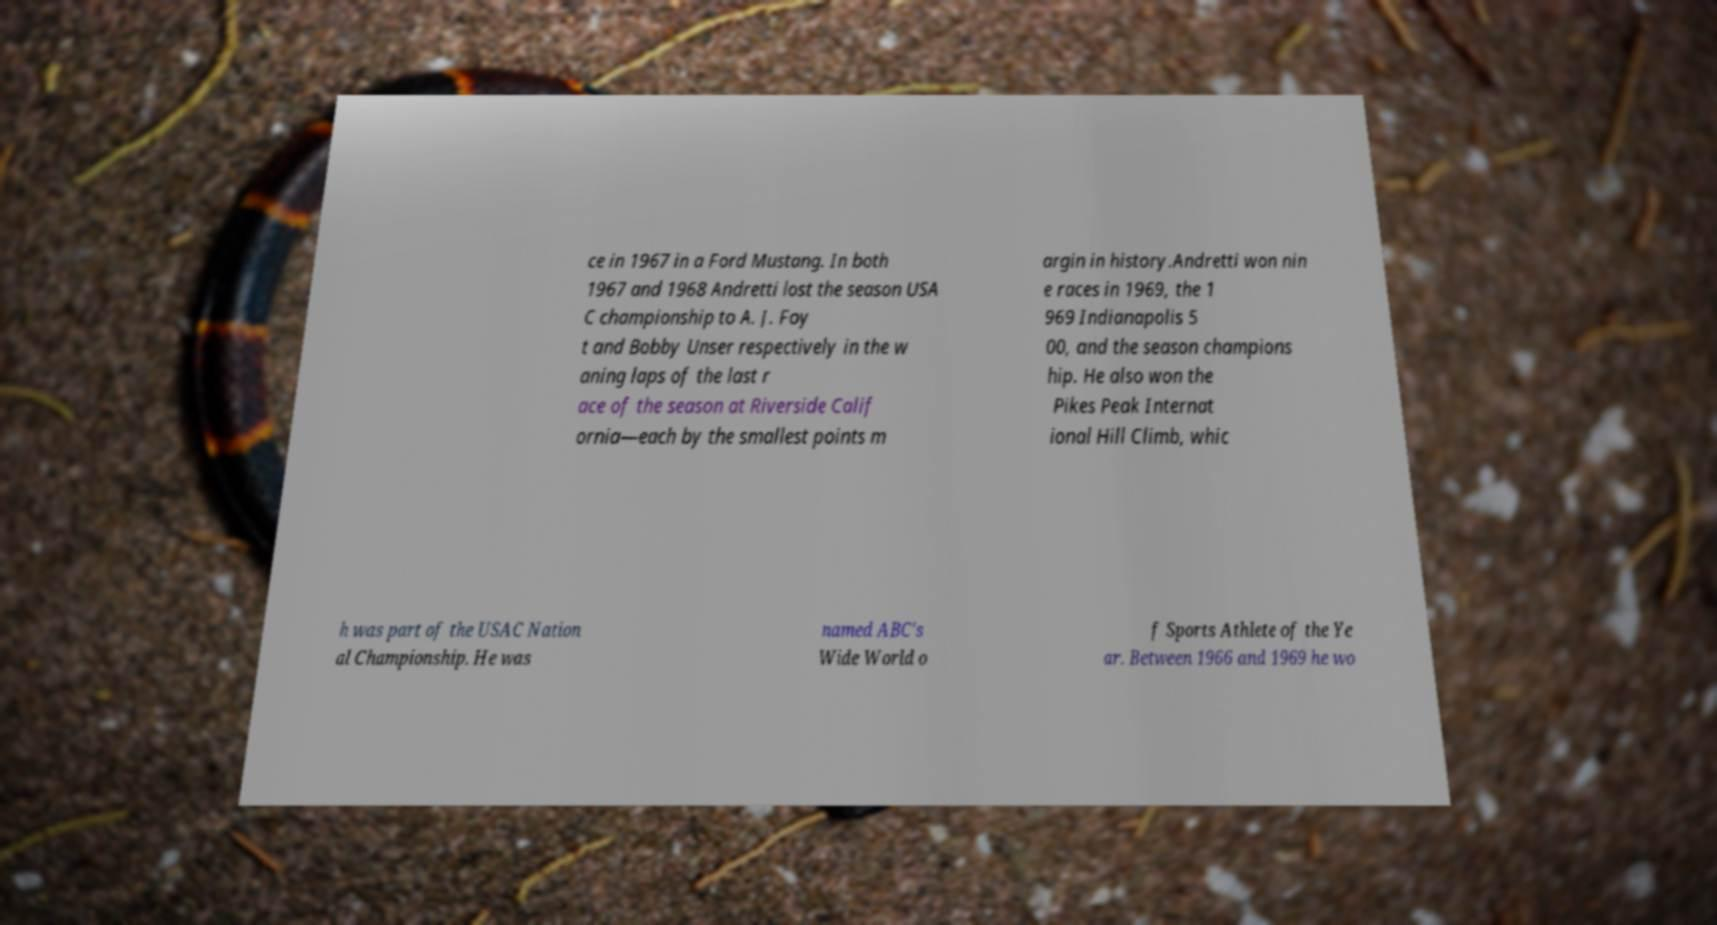Please identify and transcribe the text found in this image. ce in 1967 in a Ford Mustang. In both 1967 and 1968 Andretti lost the season USA C championship to A. J. Foy t and Bobby Unser respectively in the w aning laps of the last r ace of the season at Riverside Calif ornia—each by the smallest points m argin in history.Andretti won nin e races in 1969, the 1 969 Indianapolis 5 00, and the season champions hip. He also won the Pikes Peak Internat ional Hill Climb, whic h was part of the USAC Nation al Championship. He was named ABC's Wide World o f Sports Athlete of the Ye ar. Between 1966 and 1969 he wo 